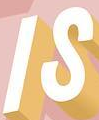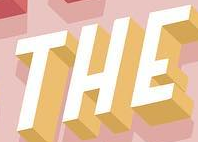What words are shown in these images in order, separated by a semicolon? IS; THE 